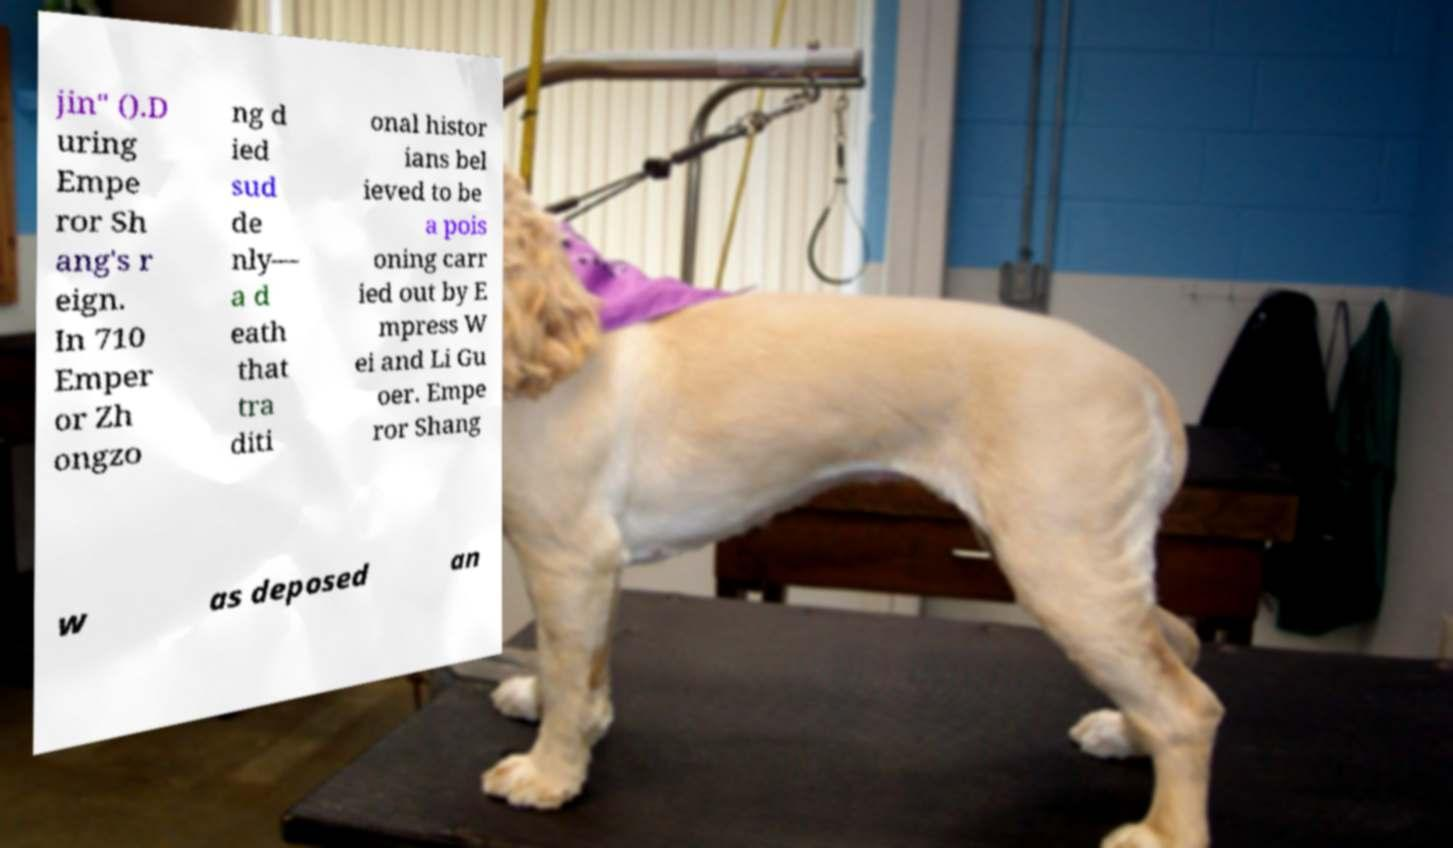For documentation purposes, I need the text within this image transcribed. Could you provide that? jin" ().D uring Empe ror Sh ang's r eign. In 710 Emper or Zh ongzo ng d ied sud de nly— a d eath that tra diti onal histor ians bel ieved to be a pois oning carr ied out by E mpress W ei and Li Gu oer. Empe ror Shang w as deposed an 